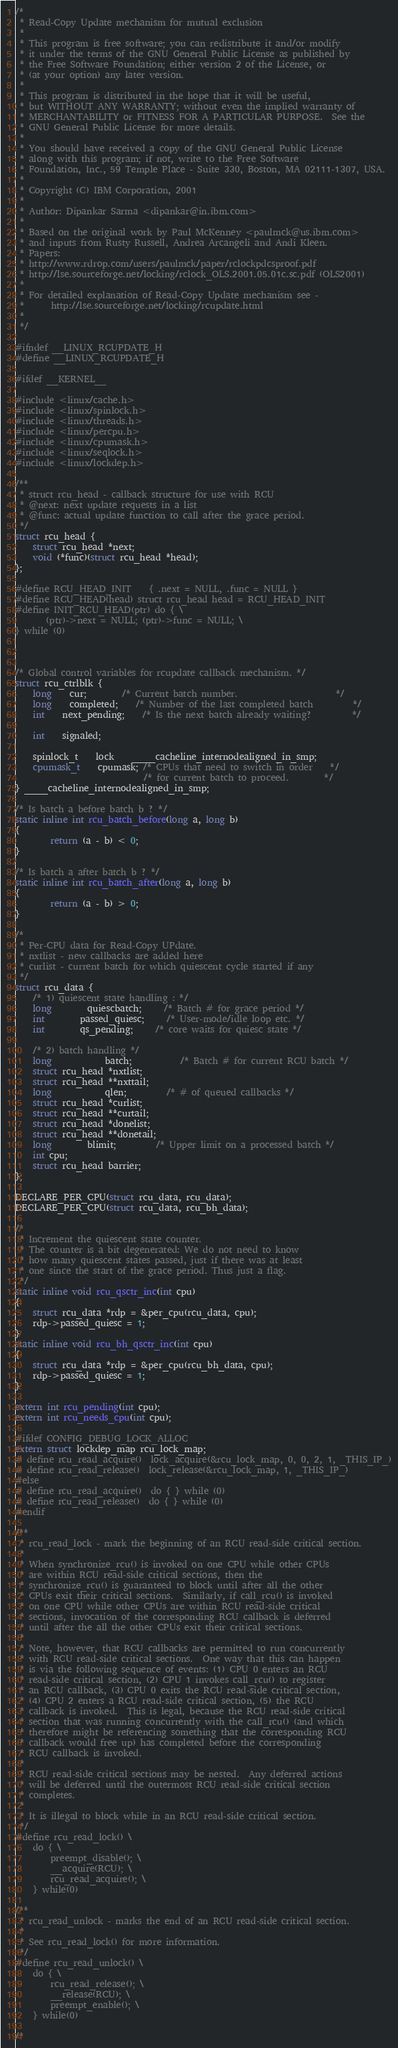Convert code to text. <code><loc_0><loc_0><loc_500><loc_500><_C_>/*
 * Read-Copy Update mechanism for mutual exclusion 
 *
 * This program is free software; you can redistribute it and/or modify
 * it under the terms of the GNU General Public License as published by
 * the Free Software Foundation; either version 2 of the License, or
 * (at your option) any later version.
 *
 * This program is distributed in the hope that it will be useful,
 * but WITHOUT ANY WARRANTY; without even the implied warranty of
 * MERCHANTABILITY or FITNESS FOR A PARTICULAR PURPOSE.  See the
 * GNU General Public License for more details.
 *
 * You should have received a copy of the GNU General Public License
 * along with this program; if not, write to the Free Software
 * Foundation, Inc., 59 Temple Place - Suite 330, Boston, MA 02111-1307, USA.
 *
 * Copyright (C) IBM Corporation, 2001
 *
 * Author: Dipankar Sarma <dipankar@in.ibm.com>
 * 
 * Based on the original work by Paul McKenney <paulmck@us.ibm.com>
 * and inputs from Rusty Russell, Andrea Arcangeli and Andi Kleen.
 * Papers:
 * http://www.rdrop.com/users/paulmck/paper/rclockpdcsproof.pdf
 * http://lse.sourceforge.net/locking/rclock_OLS.2001.05.01c.sc.pdf (OLS2001)
 *
 * For detailed explanation of Read-Copy Update mechanism see -
 * 		http://lse.sourceforge.net/locking/rcupdate.html
 *
 */

#ifndef __LINUX_RCUPDATE_H
#define __LINUX_RCUPDATE_H

#ifdef __KERNEL__

#include <linux/cache.h>
#include <linux/spinlock.h>
#include <linux/threads.h>
#include <linux/percpu.h>
#include <linux/cpumask.h>
#include <linux/seqlock.h>
#include <linux/lockdep.h>

/**
 * struct rcu_head - callback structure for use with RCU
 * @next: next update requests in a list
 * @func: actual update function to call after the grace period.
 */
struct rcu_head {
	struct rcu_head *next;
	void (*func)(struct rcu_head *head);
};

#define RCU_HEAD_INIT 	{ .next = NULL, .func = NULL }
#define RCU_HEAD(head) struct rcu_head head = RCU_HEAD_INIT
#define INIT_RCU_HEAD(ptr) do { \
       (ptr)->next = NULL; (ptr)->func = NULL; \
} while (0)



/* Global control variables for rcupdate callback mechanism. */
struct rcu_ctrlblk {
	long	cur;		/* Current batch number.                      */
	long	completed;	/* Number of the last completed batch         */
	int	next_pending;	/* Is the next batch already waiting?         */

	int	signaled;

	spinlock_t	lock	____cacheline_internodealigned_in_smp;
	cpumask_t	cpumask; /* CPUs that need to switch in order    */
	                         /* for current batch to proceed.        */
} ____cacheline_internodealigned_in_smp;

/* Is batch a before batch b ? */
static inline int rcu_batch_before(long a, long b)
{
        return (a - b) < 0;
}

/* Is batch a after batch b ? */
static inline int rcu_batch_after(long a, long b)
{
        return (a - b) > 0;
}

/*
 * Per-CPU data for Read-Copy UPdate.
 * nxtlist - new callbacks are added here
 * curlist - current batch for which quiescent cycle started if any
 */
struct rcu_data {
	/* 1) quiescent state handling : */
	long		quiescbatch;     /* Batch # for grace period */
	int		passed_quiesc;	 /* User-mode/idle loop etc. */
	int		qs_pending;	 /* core waits for quiesc state */

	/* 2) batch handling */
	long  	       	batch;           /* Batch # for current RCU batch */
	struct rcu_head *nxtlist;
	struct rcu_head **nxttail;
	long            qlen; 	 	 /* # of queued callbacks */
	struct rcu_head *curlist;
	struct rcu_head **curtail;
	struct rcu_head *donelist;
	struct rcu_head **donetail;
	long		blimit;		 /* Upper limit on a processed batch */
	int cpu;
	struct rcu_head barrier;
};

DECLARE_PER_CPU(struct rcu_data, rcu_data);
DECLARE_PER_CPU(struct rcu_data, rcu_bh_data);

/*
 * Increment the quiescent state counter.
 * The counter is a bit degenerated: We do not need to know
 * how many quiescent states passed, just if there was at least
 * one since the start of the grace period. Thus just a flag.
 */
static inline void rcu_qsctr_inc(int cpu)
{
	struct rcu_data *rdp = &per_cpu(rcu_data, cpu);
	rdp->passed_quiesc = 1;
}
static inline void rcu_bh_qsctr_inc(int cpu)
{
	struct rcu_data *rdp = &per_cpu(rcu_bh_data, cpu);
	rdp->passed_quiesc = 1;
}

extern int rcu_pending(int cpu);
extern int rcu_needs_cpu(int cpu);

#ifdef CONFIG_DEBUG_LOCK_ALLOC
extern struct lockdep_map rcu_lock_map;
# define rcu_read_acquire()	lock_acquire(&rcu_lock_map, 0, 0, 2, 1, _THIS_IP_)
# define rcu_read_release()	lock_release(&rcu_lock_map, 1, _THIS_IP_)
#else
# define rcu_read_acquire()	do { } while (0)
# define rcu_read_release()	do { } while (0)
#endif

/**
 * rcu_read_lock - mark the beginning of an RCU read-side critical section.
 *
 * When synchronize_rcu() is invoked on one CPU while other CPUs
 * are within RCU read-side critical sections, then the
 * synchronize_rcu() is guaranteed to block until after all the other
 * CPUs exit their critical sections.  Similarly, if call_rcu() is invoked
 * on one CPU while other CPUs are within RCU read-side critical
 * sections, invocation of the corresponding RCU callback is deferred
 * until after the all the other CPUs exit their critical sections.
 *
 * Note, however, that RCU callbacks are permitted to run concurrently
 * with RCU read-side critical sections.  One way that this can happen
 * is via the following sequence of events: (1) CPU 0 enters an RCU
 * read-side critical section, (2) CPU 1 invokes call_rcu() to register
 * an RCU callback, (3) CPU 0 exits the RCU read-side critical section,
 * (4) CPU 2 enters a RCU read-side critical section, (5) the RCU
 * callback is invoked.  This is legal, because the RCU read-side critical
 * section that was running concurrently with the call_rcu() (and which
 * therefore might be referencing something that the corresponding RCU
 * callback would free up) has completed before the corresponding
 * RCU callback is invoked.
 *
 * RCU read-side critical sections may be nested.  Any deferred actions
 * will be deferred until the outermost RCU read-side critical section
 * completes.
 *
 * It is illegal to block while in an RCU read-side critical section.
 */
#define rcu_read_lock() \
	do { \
		preempt_disable(); \
		__acquire(RCU); \
		rcu_read_acquire(); \
	} while(0)

/**
 * rcu_read_unlock - marks the end of an RCU read-side critical section.
 *
 * See rcu_read_lock() for more information.
 */
#define rcu_read_unlock() \
	do { \
		rcu_read_release(); \
		__release(RCU); \
		preempt_enable(); \
	} while(0)

/*</code> 